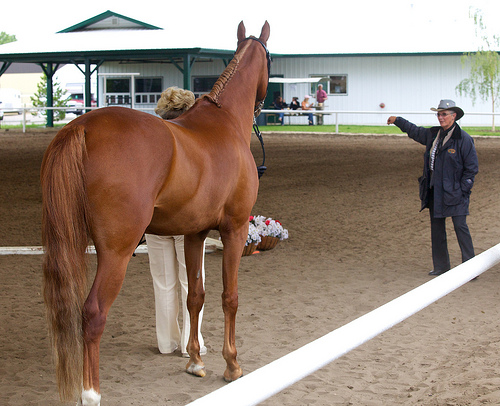<image>
Is there a horse under the roof? No. The horse is not positioned under the roof. The vertical relationship between these objects is different. Is the woman in front of the horse? No. The woman is not in front of the horse. The spatial positioning shows a different relationship between these objects. 